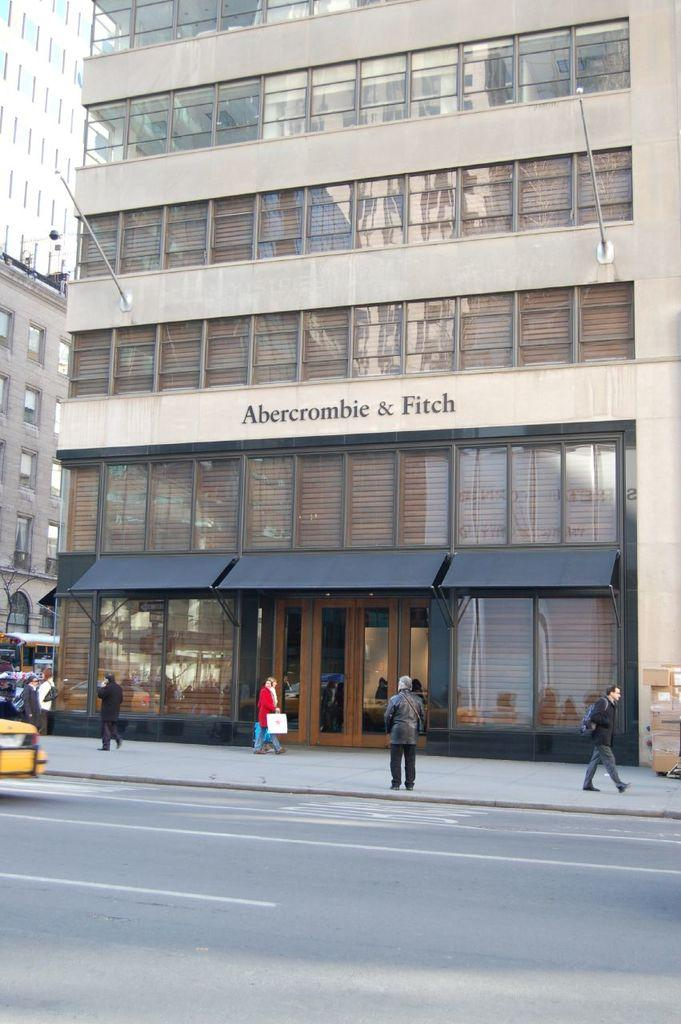What is the main feature of the image? There is a road in the image. What are the people in the image doing? There are people walking on the sidewalk. What can be seen in the distance in the image? There are buildings in the background of the image. What type of wound can be seen on the woman in the image? There is no woman present in the image, and therefore no wound can be observed. What color is the notebook on the road in the image? There is no notebook present in the image. 